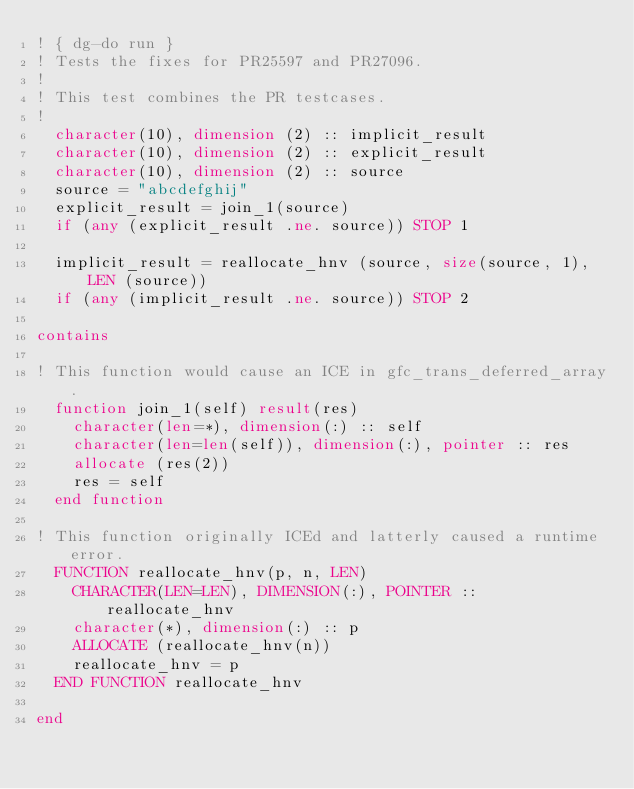Convert code to text. <code><loc_0><loc_0><loc_500><loc_500><_FORTRAN_>! { dg-do run }
! Tests the fixes for PR25597 and PR27096.
!
! This test combines the PR testcases.
!
  character(10), dimension (2) :: implicit_result
  character(10), dimension (2) :: explicit_result
  character(10), dimension (2) :: source
  source = "abcdefghij"
  explicit_result = join_1(source)
  if (any (explicit_result .ne. source)) STOP 1 

  implicit_result = reallocate_hnv (source, size(source, 1), LEN (source))
  if (any (implicit_result .ne. source)) STOP 2 

contains

! This function would cause an ICE in gfc_trans_deferred_array.
  function join_1(self) result(res)
    character(len=*), dimension(:) :: self
    character(len=len(self)), dimension(:), pointer :: res
    allocate (res(2))
    res = self
  end function

! This function originally ICEd and latterly caused a runtime error.
  FUNCTION reallocate_hnv(p, n, LEN)
    CHARACTER(LEN=LEN), DIMENSION(:), POINTER :: reallocate_hnv
    character(*), dimension(:) :: p
    ALLOCATE (reallocate_hnv(n))
    reallocate_hnv = p
  END FUNCTION reallocate_hnv

end

 
</code> 